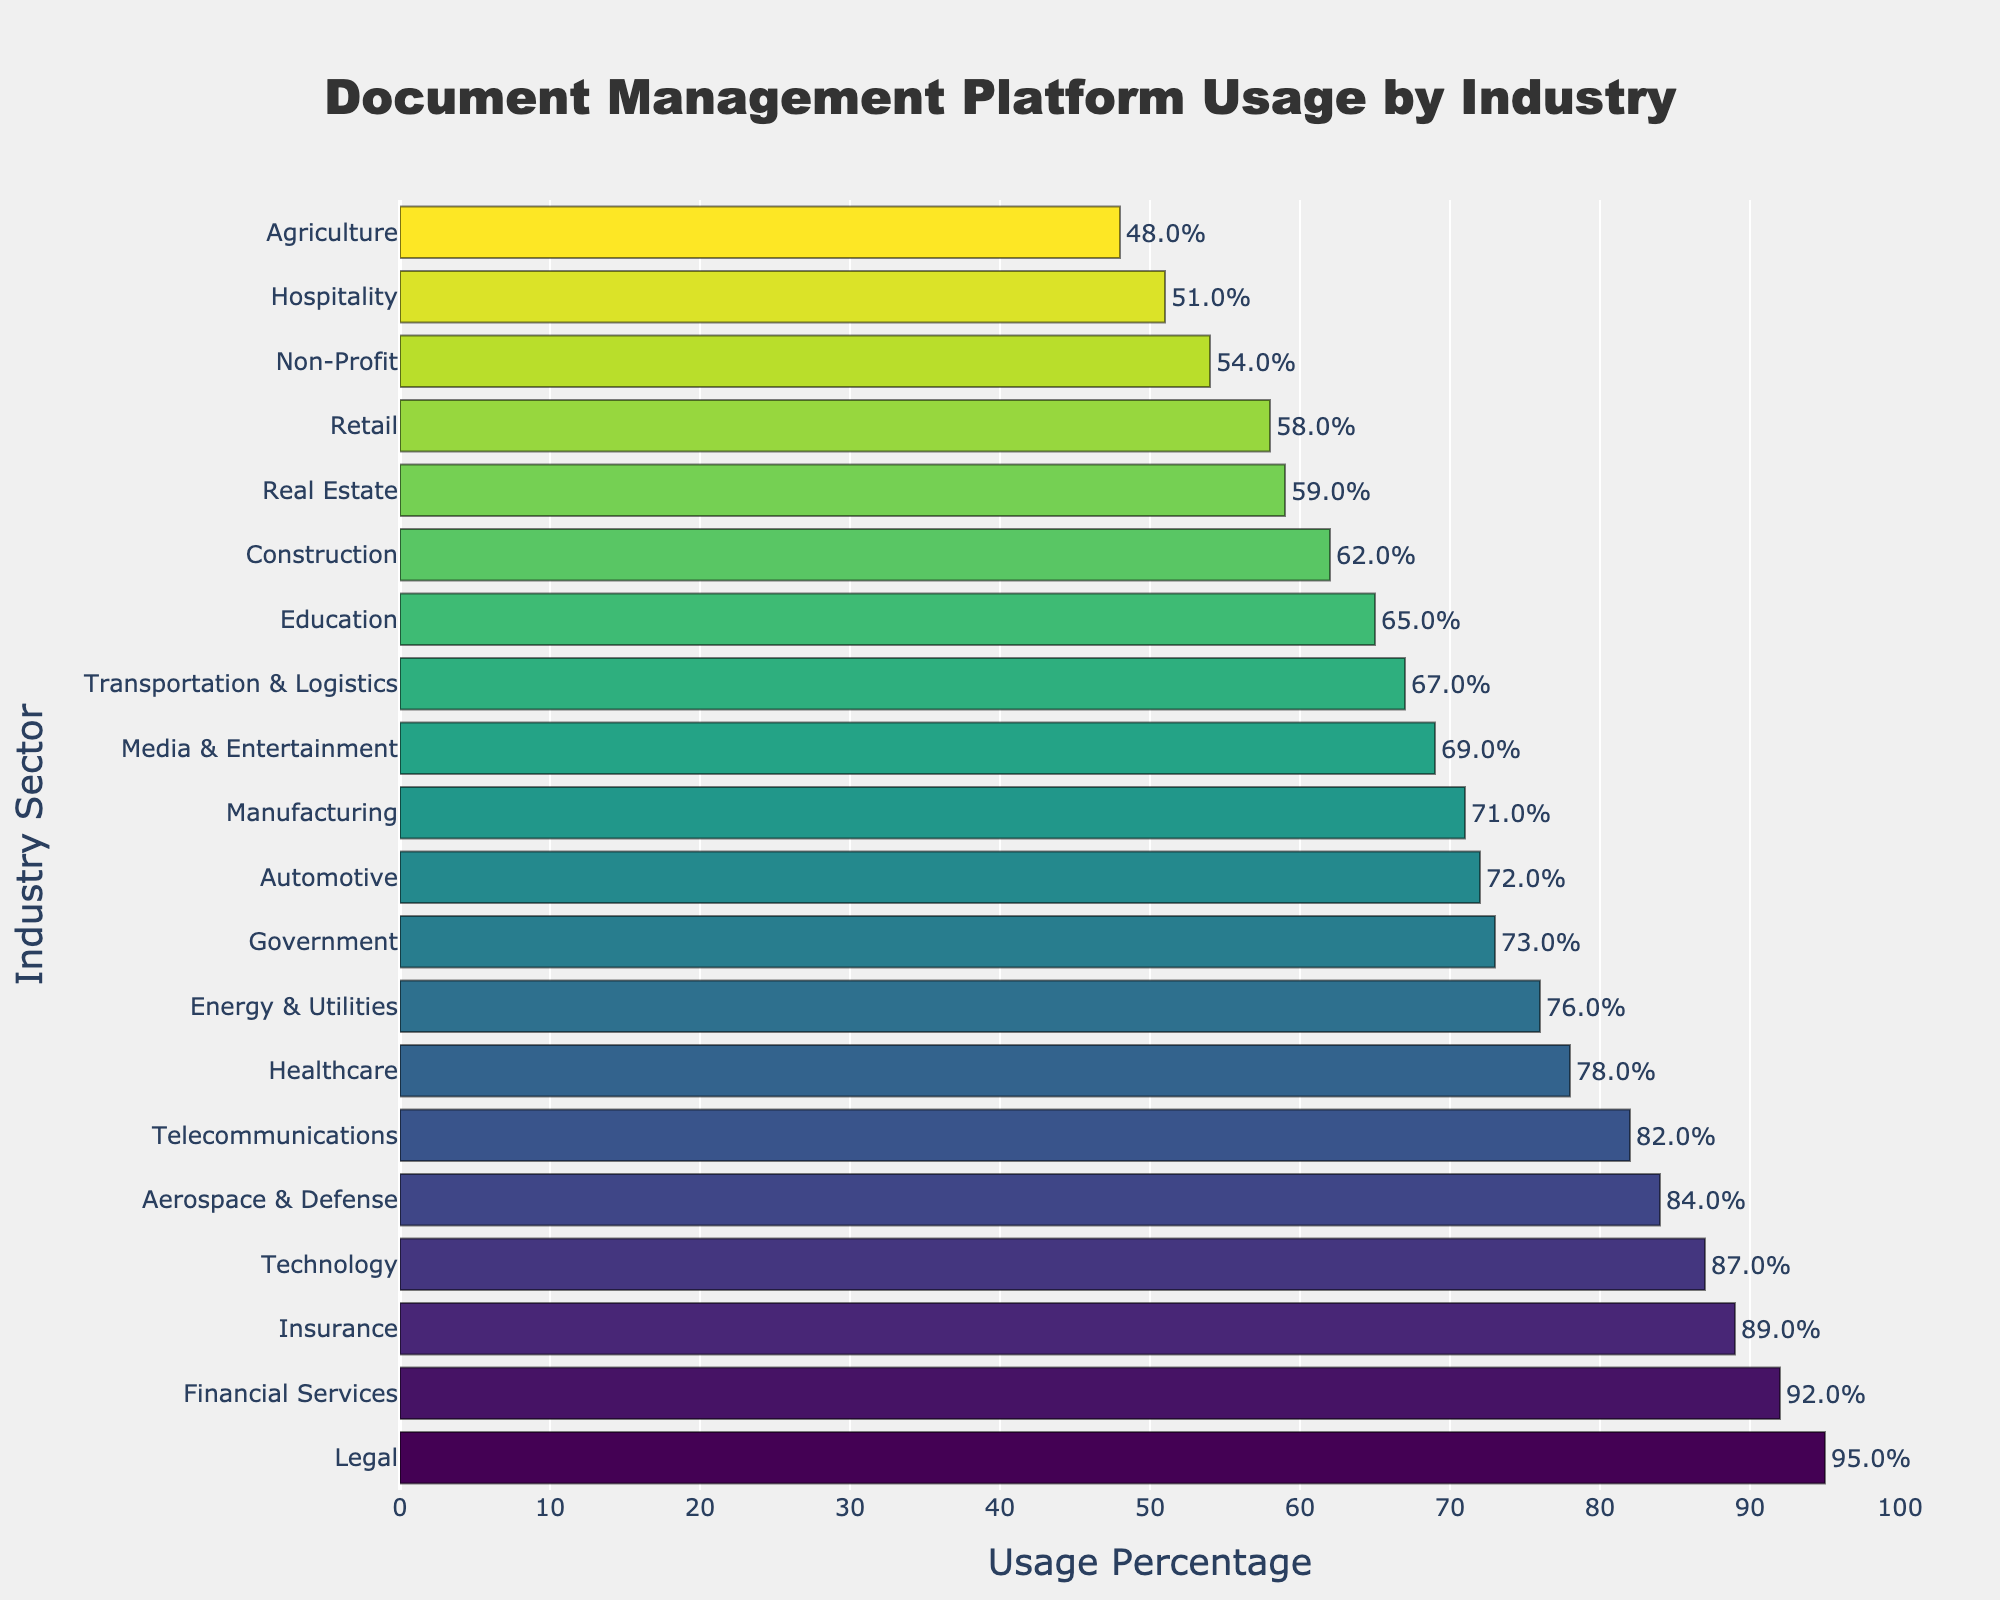Which industry has the highest usage of document management platforms? Look for the longest bar in the chart. The Legal industry has the highest usage.
Answer: Legal What is the difference in usage percentage between the Financial Services sector and the Non-Profit sector? The Financial Services sector has 92% usage, and the Non-Profit sector has 54% usage. The difference is 92% - 54% = 38%.
Answer: 38% How many industries have a document management platform usage percentage above 80%? Count the number of bars that extend beyond the 80% mark. The industries are Financial Services, Legal, Technology, Telecommunications, Insurance, and Aerospace & Defense. There are 6 industries.
Answer: 6 Which industry has a usage percentage closest to 70%? Identify the bar nearest to the 70% mark. Both Manufacturing (71%) and Media & Entertainment (69%) are close, but Media & Entertainment is the closest.
Answer: Media & Entertainment What is the sum of the usage percentages for the Healthcare, Technology, and Insurance sectors? Add the percentages of these sectors: Healthcare (78%) + Technology (87%) + Insurance (89%) = 78 + 87 + 89 = 254%
Answer: 254% Are there more sectors with usage percentages above 60% or below 60%? Count the bars above and below the 60% line. Above 60%: 15 sectors (Healthcare, Financial Services, Legal, Education, Manufacturing, Retail, Technology, Government, Construction, Media & Entertainment, Transportation & Logistics, Energy & Utilities, Real Estate, Telecommunications, Insurance, Aerospace & Defense, Automotive). Below 60%: 4 sectors (Non-Profit, Hospitality, Agriculture). More sectors are above 60%.
Answer: Above 60% What is the average usage percentage of the sectors in the chart? Sum all the usage percentages and divide by the number of sectors: (78 + 92 + 95 + 65 + 71 + 58 + 87 + 73 + 62 + 54 + 69 + 67 + 76 + 59 + 51 + 82 + 89 + 48 + 84 + 72) / 20. The sum is 1524, and dividing by 20 gives 76.2%.
Answer: 76.2% Which sector has the third-highest usage percentage? Look at the sorted bars, the third-longest is the Legal industry (95%), Financial Services (92%), followed by Insurance (89%). The third-highest is Insurance.
Answer: Insurance How much higher is the usage percentage in the Healthcare sector compared to the Agriculture sector? The Healthcare sector has 78% usage, and the Agriculture sector has 48% usage. The difference is 78% - 48% = 30%.
Answer: 30% Which sectors have a usage percentage equal to or greater than 90%? Identify the bars that are at least 90% long. The sectors are Financial Services (92%), Legal (95%).
Answer: Financial Services, Legal 